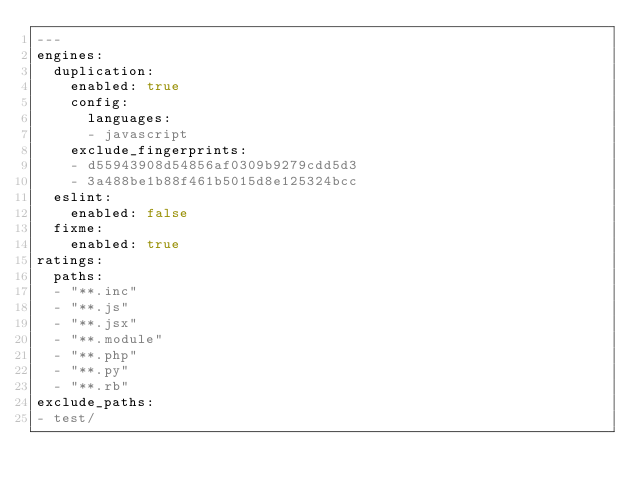<code> <loc_0><loc_0><loc_500><loc_500><_YAML_>---
engines:
  duplication:
    enabled: true
    config:
      languages:
      - javascript
    exclude_fingerprints:
    - d55943908d54856af0309b9279cdd5d3
    - 3a488be1b88f461b5015d8e125324bcc
  eslint:
    enabled: false
  fixme:
    enabled: true
ratings:
  paths:
  - "**.inc"
  - "**.js"
  - "**.jsx"
  - "**.module"
  - "**.php"
  - "**.py"
  - "**.rb"
exclude_paths:
- test/
</code> 